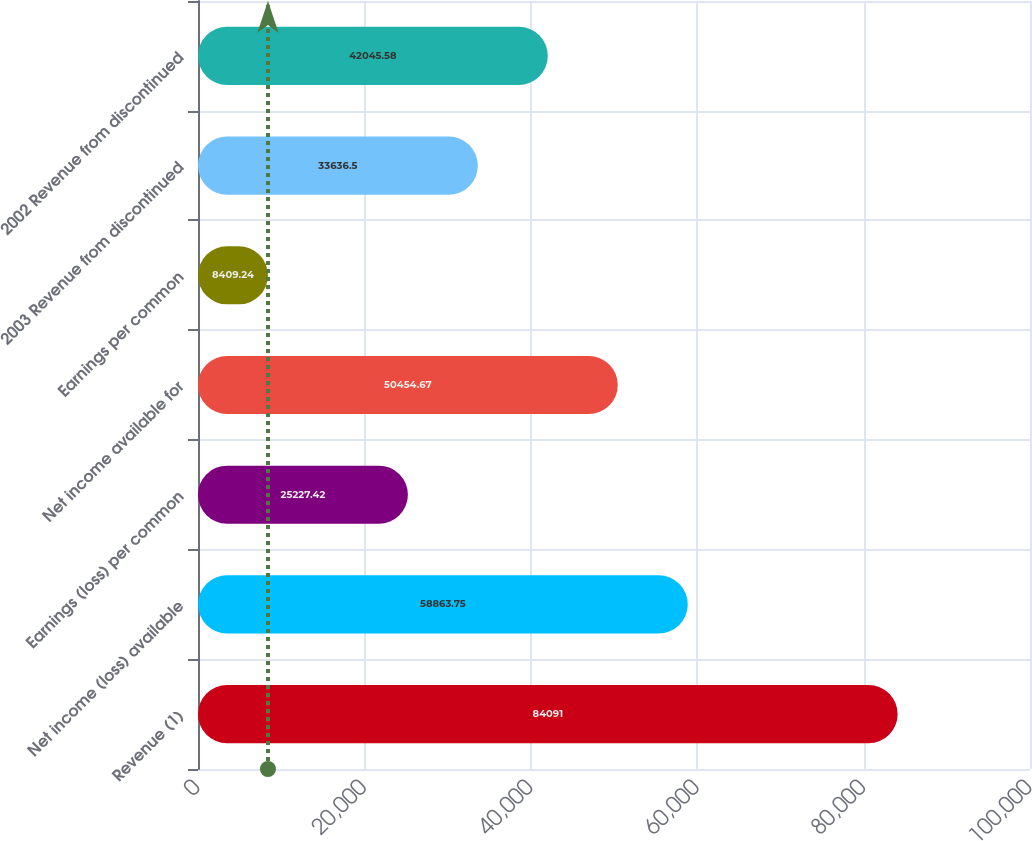Convert chart. <chart><loc_0><loc_0><loc_500><loc_500><bar_chart><fcel>Revenue (1)<fcel>Net income (loss) available<fcel>Earnings (loss) per common<fcel>Net income available for<fcel>Earnings per common<fcel>2003 Revenue from discontinued<fcel>2002 Revenue from discontinued<nl><fcel>84091<fcel>58863.8<fcel>25227.4<fcel>50454.7<fcel>8409.24<fcel>33636.5<fcel>42045.6<nl></chart> 